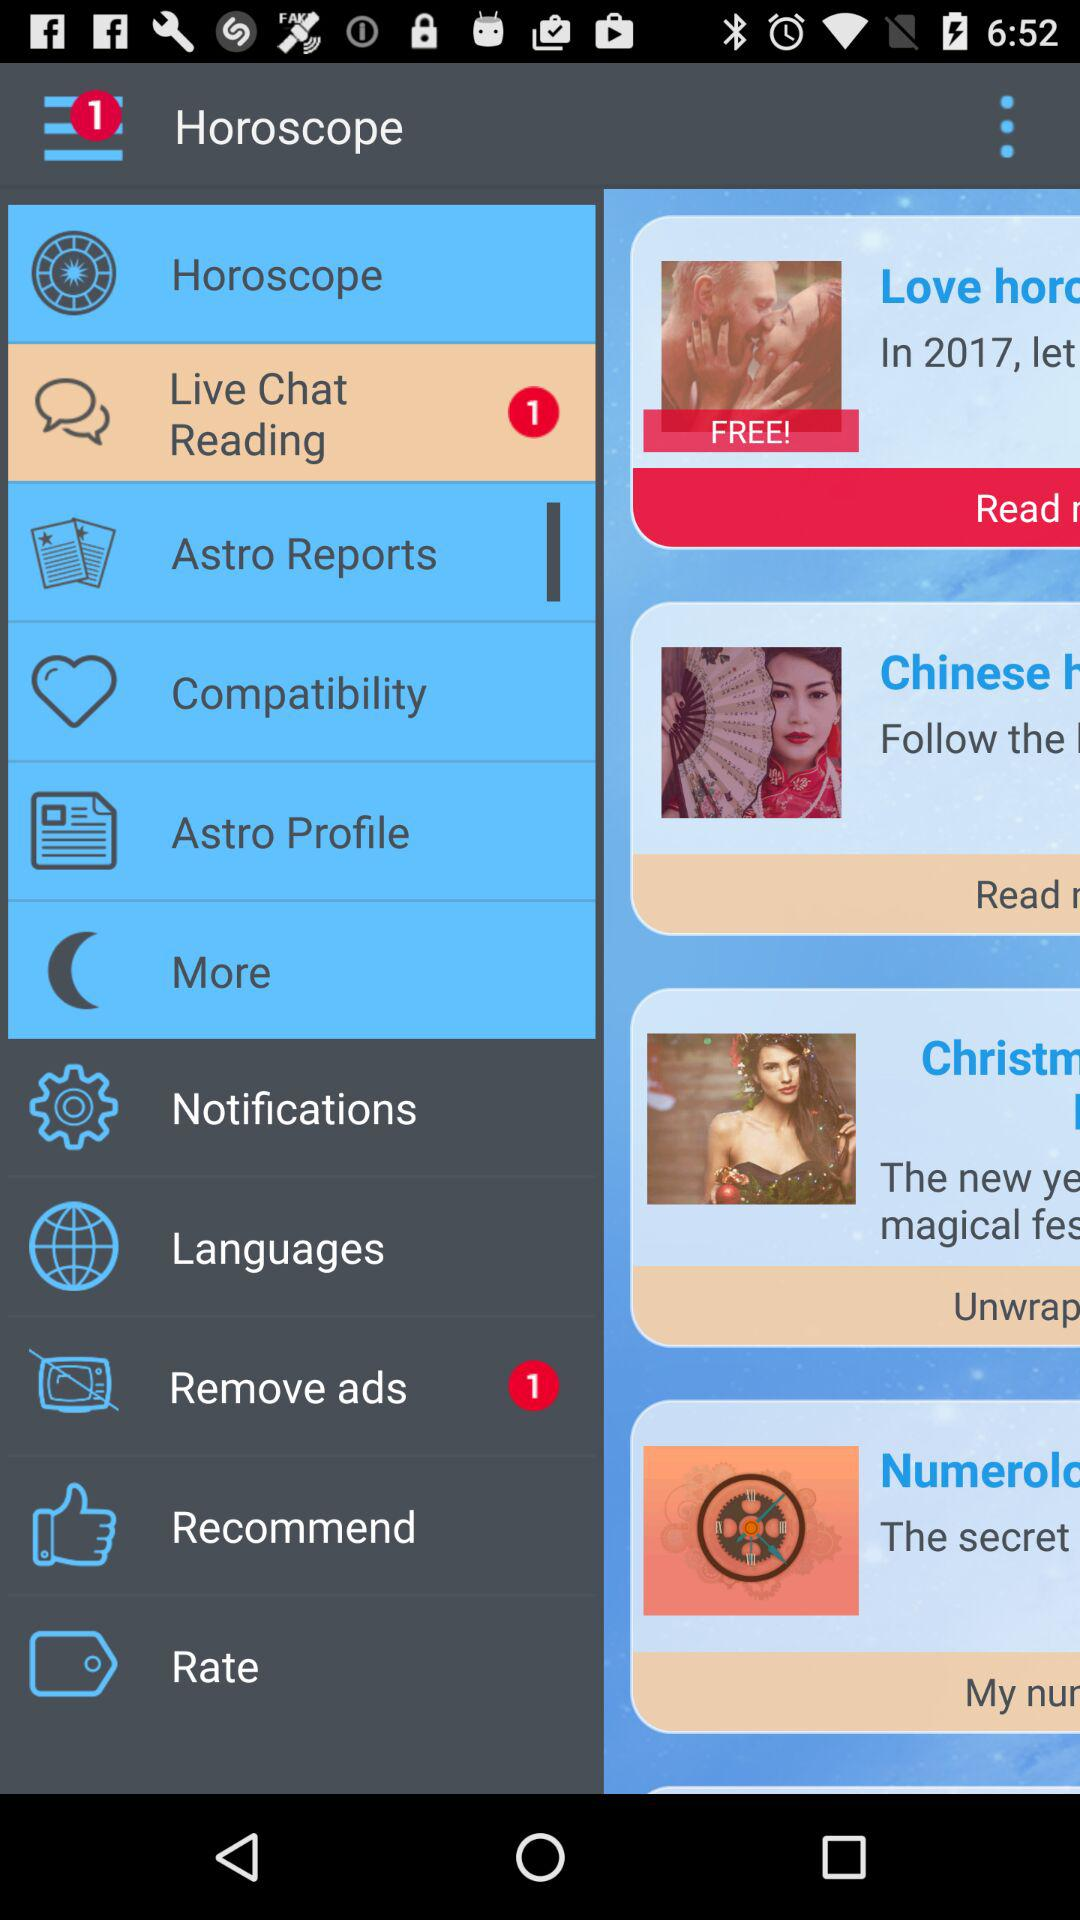What is the name of the application? The name of the application is "Horoscope". 